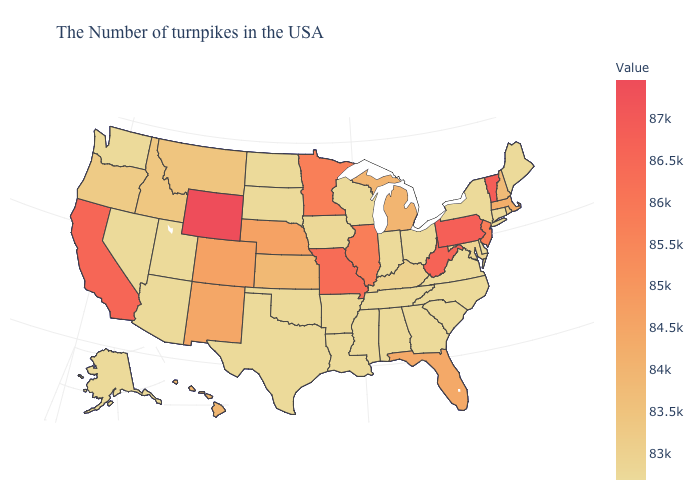Which states have the lowest value in the Northeast?
Keep it brief. Maine, Connecticut, New York. Does the map have missing data?
Give a very brief answer. No. Which states hav the highest value in the Northeast?
Quick response, please. Vermont. Which states hav the highest value in the Northeast?
Quick response, please. Vermont. 